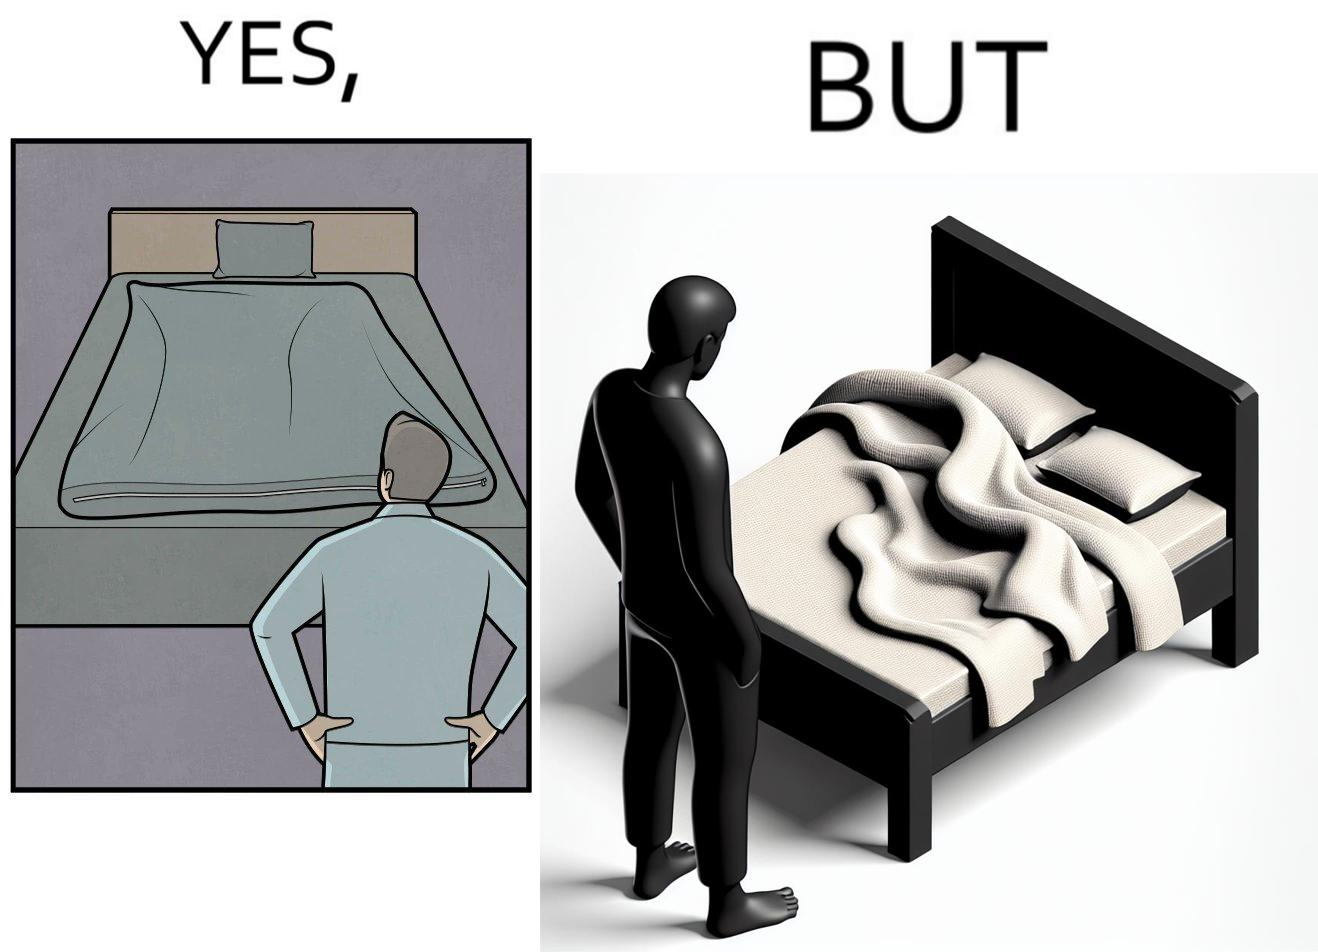Provide a description of this image. The image is funny because while the bed seems to be well made with the blanket on top, the actual blanket inside the blanket cover is twisted and not properly set. 